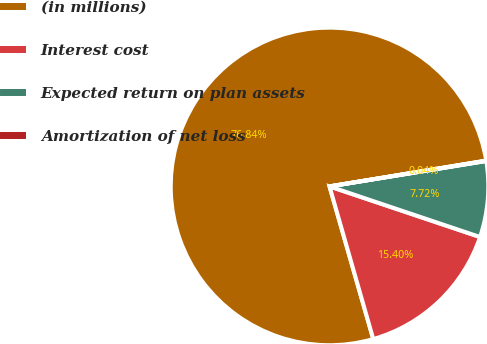Convert chart to OTSL. <chart><loc_0><loc_0><loc_500><loc_500><pie_chart><fcel>(in millions)<fcel>Interest cost<fcel>Expected return on plan assets<fcel>Amortization of net loss<nl><fcel>76.84%<fcel>15.4%<fcel>7.72%<fcel>0.04%<nl></chart> 